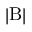Convert formula to latex. <formula><loc_0><loc_0><loc_500><loc_500>| B |</formula> 